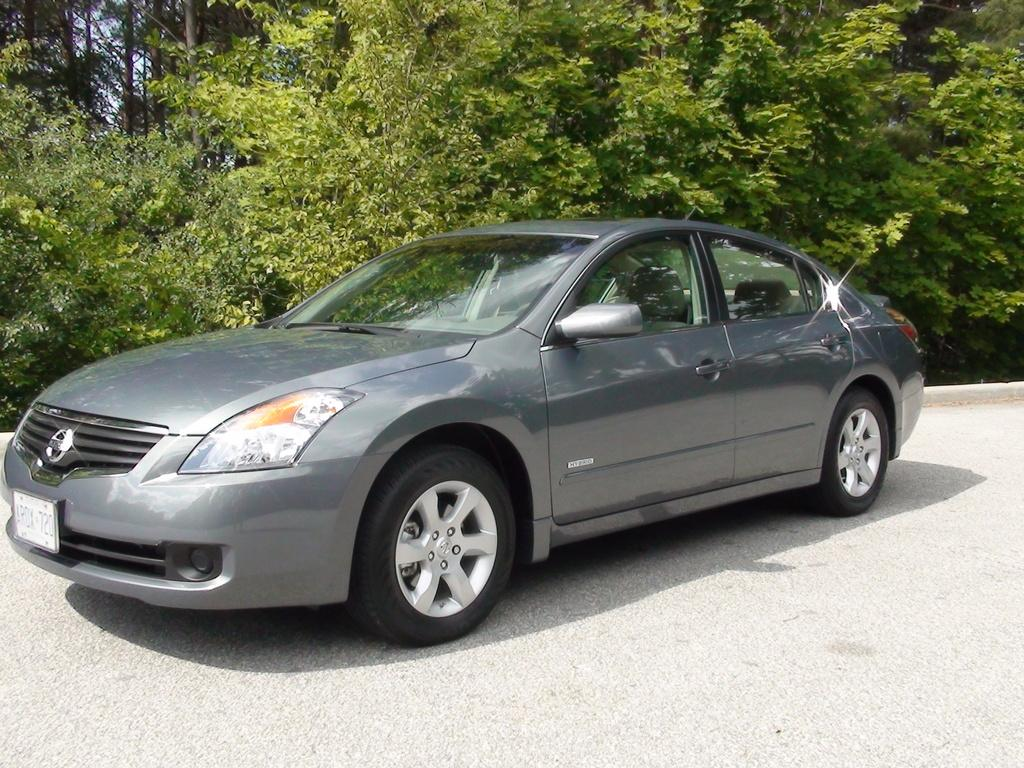Provide a one-sentence caption for the provided image. A grey hybrid automobile with the license plate number AROX 720. 